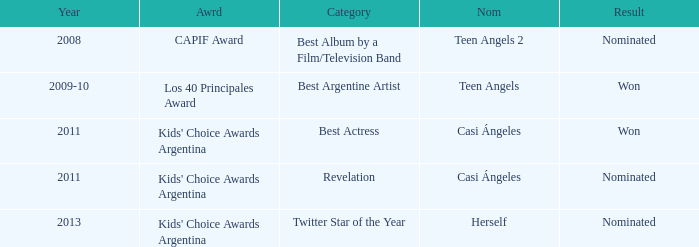Name the performance nominated for a Capif Award. Teen Angels 2. 